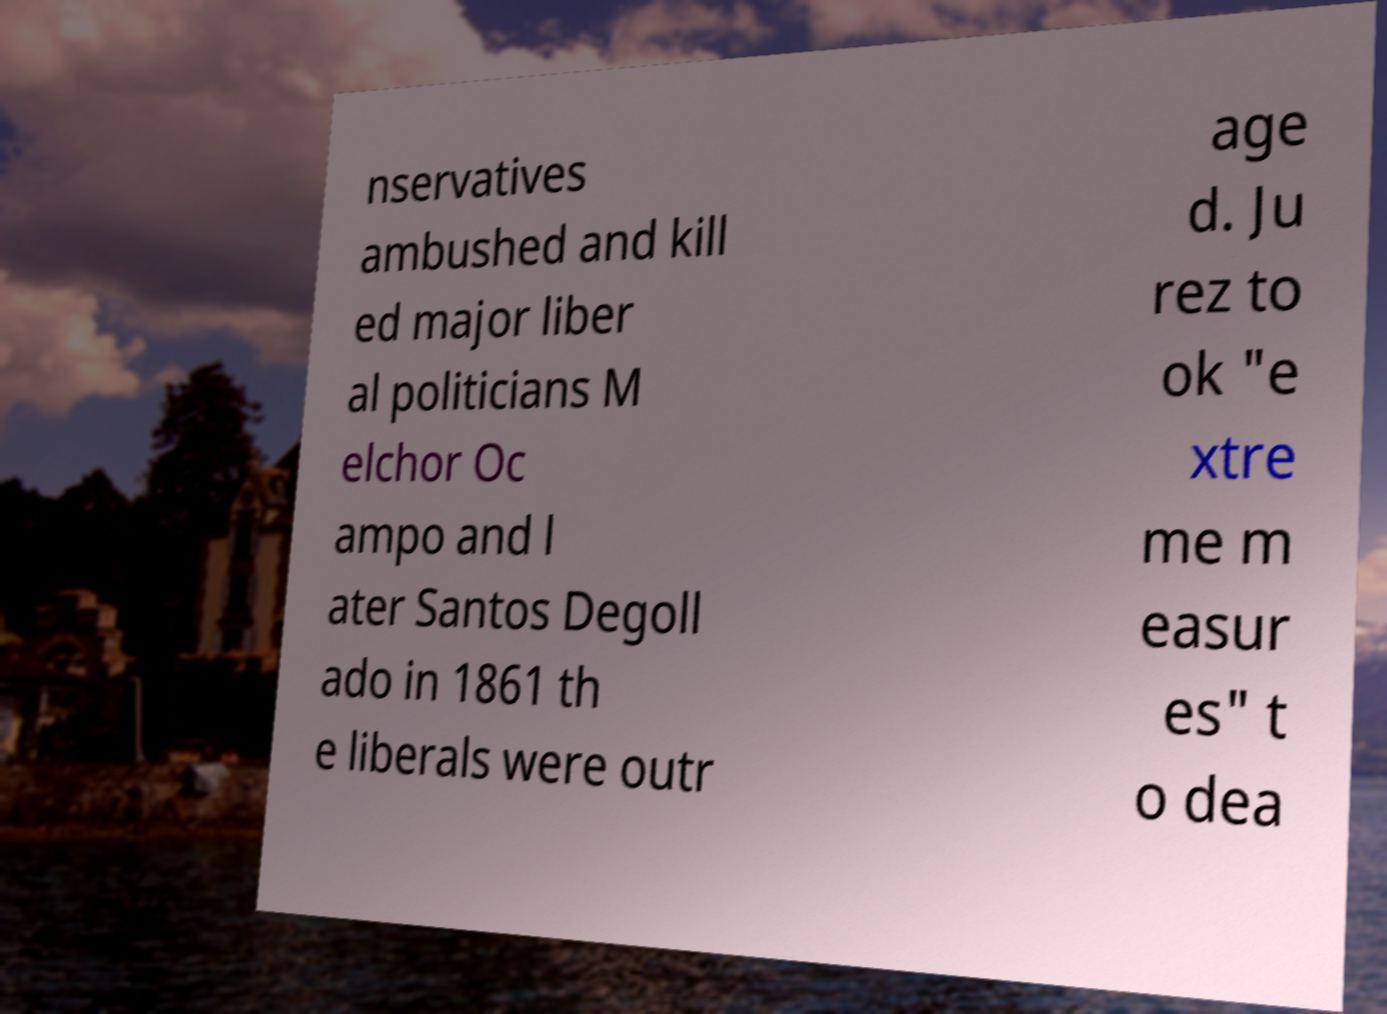I need the written content from this picture converted into text. Can you do that? nservatives ambushed and kill ed major liber al politicians M elchor Oc ampo and l ater Santos Degoll ado in 1861 th e liberals were outr age d. Ju rez to ok "e xtre me m easur es" t o dea 